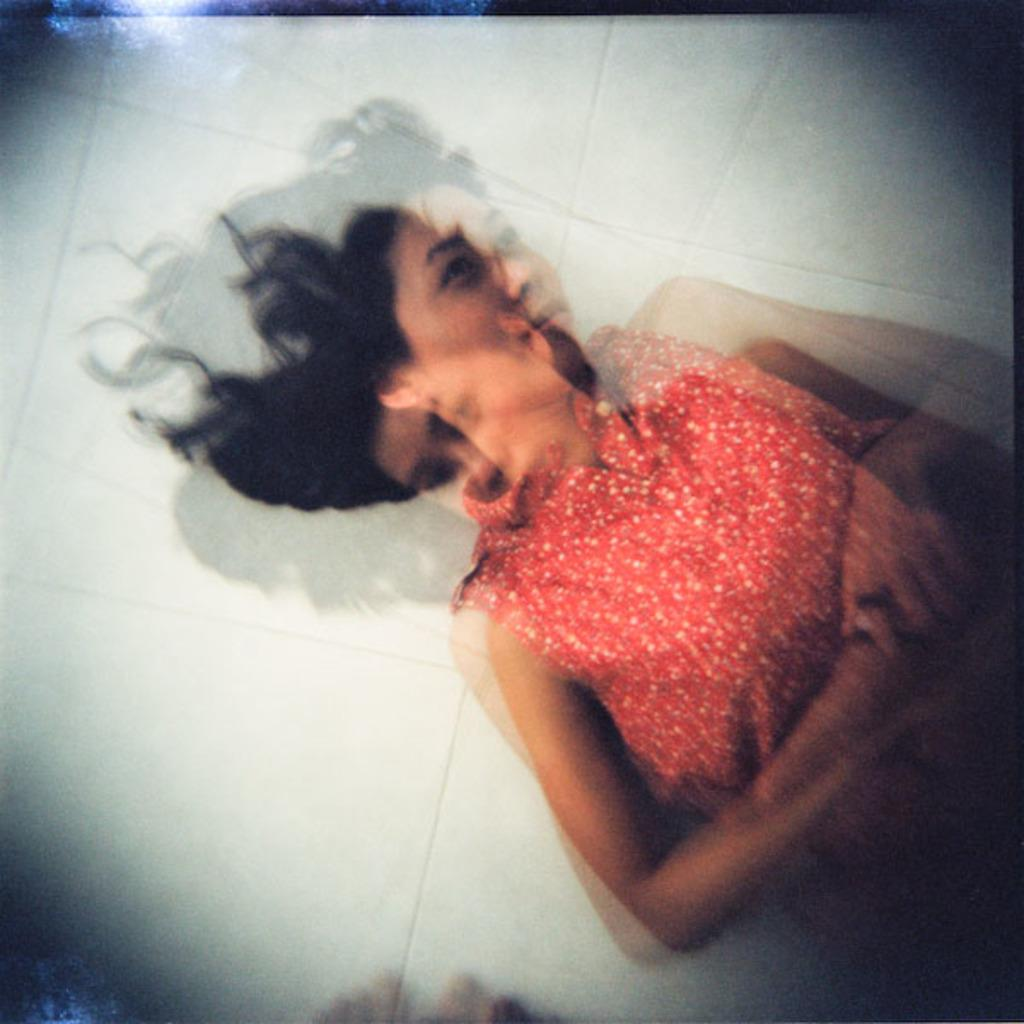Who or what is the main subject in the image? There is a person in the image. What is the person wearing? The person is wearing an orange dress. What color is the background of the image? The background of the image is white. How many dimes can be seen on the person's head in the image? There are no dimes present in the image, and the person's head is not visible. 